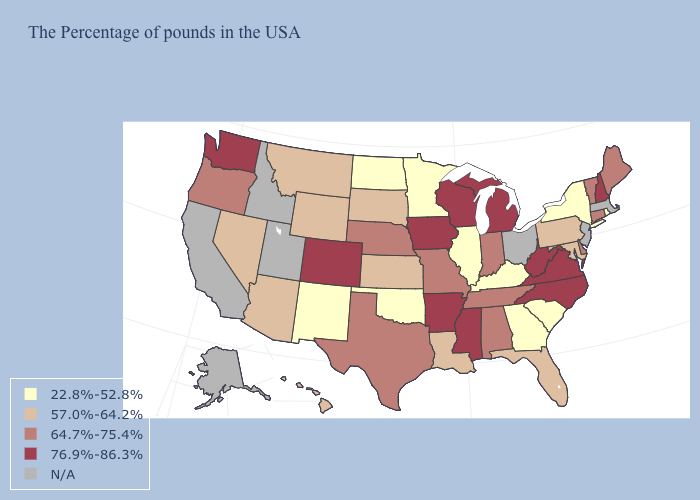What is the value of Hawaii?
Give a very brief answer. 57.0%-64.2%. Does the map have missing data?
Keep it brief. Yes. Among the states that border Vermont , does New York have the lowest value?
Answer briefly. Yes. How many symbols are there in the legend?
Quick response, please. 5. Which states hav the highest value in the West?
Keep it brief. Colorado, Washington. Which states have the lowest value in the West?
Quick response, please. New Mexico. Which states have the highest value in the USA?
Concise answer only. New Hampshire, Virginia, North Carolina, West Virginia, Michigan, Wisconsin, Mississippi, Arkansas, Iowa, Colorado, Washington. Name the states that have a value in the range 22.8%-52.8%?
Short answer required. Rhode Island, New York, South Carolina, Georgia, Kentucky, Illinois, Minnesota, Oklahoma, North Dakota, New Mexico. Among the states that border Texas , does Arkansas have the highest value?
Concise answer only. Yes. Does Connecticut have the highest value in the Northeast?
Keep it brief. No. Name the states that have a value in the range N/A?
Quick response, please. Massachusetts, New Jersey, Ohio, Utah, Idaho, California, Alaska. Does the map have missing data?
Short answer required. Yes. 